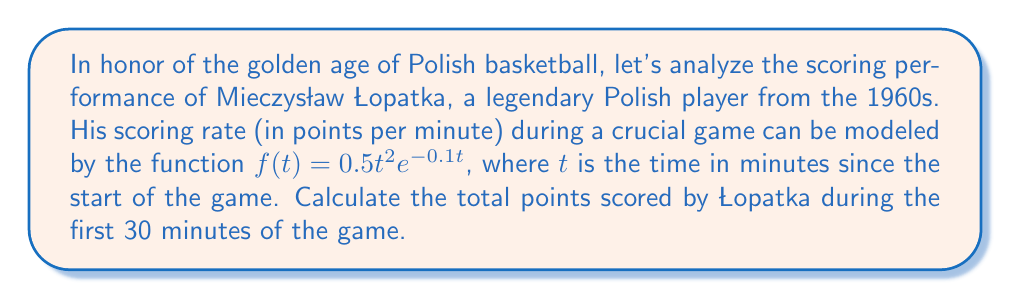Help me with this question. To find the total points scored, we need to calculate the area under the curve of the scoring rate function from $t=0$ to $t=30$. This can be done using definite integration.

1) The integral we need to evaluate is:

   $$\int_0^{30} f(t) dt = \int_0^{30} 0.5t^2e^{-0.1t} dt$$

2) This integral doesn't have an elementary antiderivative, so we'll need to use integration by parts twice.

3) Let $u = t^2$ and $dv = e^{-0.1t}dt$. Then $du = 2t dt$ and $v = -10e^{-0.1t}$.

4) Applying integration by parts:

   $$\int t^2e^{-0.1t} dt = -10t^2e^{-0.1t} + \int 20te^{-0.1t} dt$$

5) For the remaining integral, let $u = t$ and $dv = e^{-0.1t}dt$. Then $du = dt$ and $v = -10e^{-0.1t}$.

6) Applying integration by parts again:

   $$\int 20te^{-0.1t} dt = -200te^{-0.1t} + \int 200e^{-0.1t} dt$$

7) The last integral is elementary: $\int 200e^{-0.1t} dt = -2000e^{-0.1t} + C$

8) Combining all terms and multiplying by 0.5:

   $$0.5 \int_0^{30} t^2e^{-0.1t} dt = -5t^2e^{-0.1t} - 100te^{-0.1t} - 1000e^{-0.1t} + C$$

9) Evaluating from 0 to 30:

   $$[-5t^2e^{-0.1t} - 100te^{-0.1t} - 1000e^{-0.1t}]_0^{30}$$
   
   $$= [-5(30^2)e^{-3} - 100(30)e^{-3} - 1000e^{-3}] - [-5(0^2)e^0 - 100(0)e^0 - 1000e^0]$$
   
   $$= [-4500e^{-3} - 3000e^{-3} - 1000e^{-3}] - [-1000]$$
   
   $$= -8500e^{-3} + 1000 \approx 949.93$$

Therefore, Łopatka scored approximately 949.93 points during the first 30 minutes of the game.
Answer: 949.93 points 